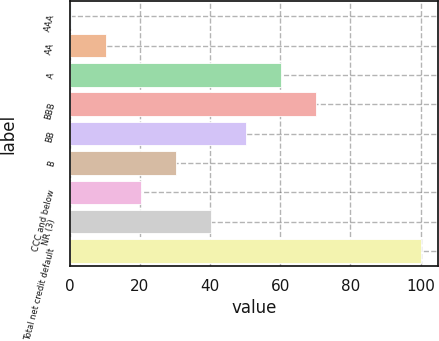Convert chart. <chart><loc_0><loc_0><loc_500><loc_500><bar_chart><fcel>AAA<fcel>AA<fcel>A<fcel>BBB<fcel>BB<fcel>B<fcel>CCC and below<fcel>NR (3)<fcel>Total net credit default<nl><fcel>0.3<fcel>10.27<fcel>60.12<fcel>70.09<fcel>50.15<fcel>30.21<fcel>20.24<fcel>40.18<fcel>100<nl></chart> 